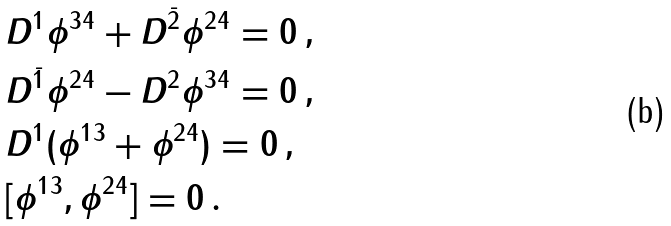Convert formula to latex. <formula><loc_0><loc_0><loc_500><loc_500>& D ^ { 1 } \phi ^ { 3 4 } + D ^ { \bar { 2 } } \phi ^ { 2 4 } = 0 \, , \\ & D ^ { \bar { 1 } } \phi ^ { 2 4 } - D ^ { 2 } \phi ^ { 3 4 } = 0 \, , \\ & D ^ { 1 } ( \phi ^ { 1 3 } + \phi ^ { 2 4 } ) = 0 \, , \\ & [ \phi ^ { 1 3 } , \phi ^ { 2 4 } ] = 0 \, . \\</formula> 